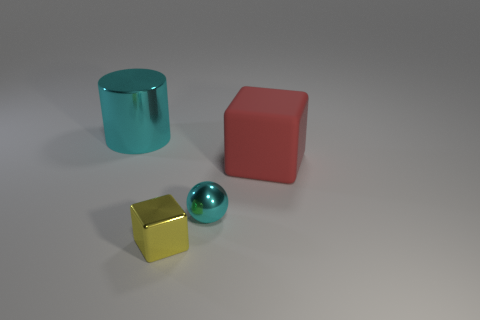Is there any other thing that has the same shape as the large cyan object?
Provide a succinct answer. No. Are there an equal number of yellow cubes that are in front of the tiny yellow shiny object and tiny shiny things that are on the right side of the metal sphere?
Your response must be concise. Yes. What number of big cyan metal objects are there?
Your answer should be very brief. 1. Are there more metallic things that are in front of the small cyan shiny ball than big gray rubber cylinders?
Offer a very short reply. Yes. What is the big thing that is right of the tiny cyan shiny sphere made of?
Keep it short and to the point. Rubber. There is a small object that is the same shape as the big red thing; what is its color?
Your response must be concise. Yellow. How many other cubes are the same color as the rubber cube?
Provide a succinct answer. 0. Do the cyan object in front of the big rubber block and the cube that is on the left side of the red cube have the same size?
Your answer should be very brief. Yes. Do the yellow metal block and the cyan object to the right of the metal cube have the same size?
Your answer should be compact. Yes. How big is the shiny cube?
Your answer should be very brief. Small. 